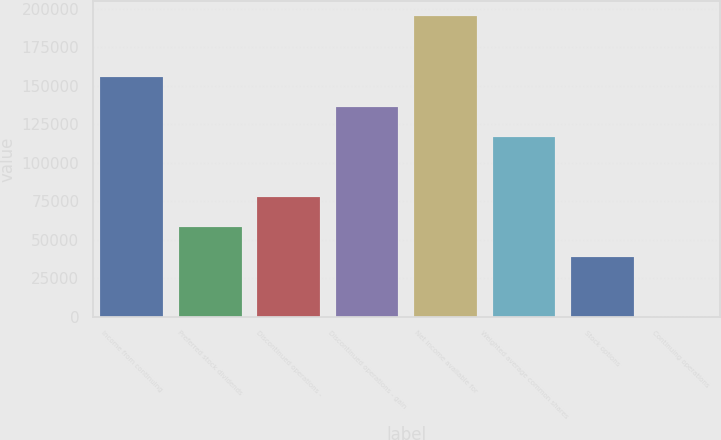Convert chart to OTSL. <chart><loc_0><loc_0><loc_500><loc_500><bar_chart><fcel>Income from continuing<fcel>Preferred stock dividends<fcel>Discontinued operations -<fcel>Discontinued operations - gain<fcel>Net income available for<fcel>Weighted average common shares<fcel>Stock options<fcel>Continuing operations<nl><fcel>156076<fcel>58529.7<fcel>78039<fcel>136567<fcel>195095<fcel>117058<fcel>39020.4<fcel>1.71<nl></chart> 